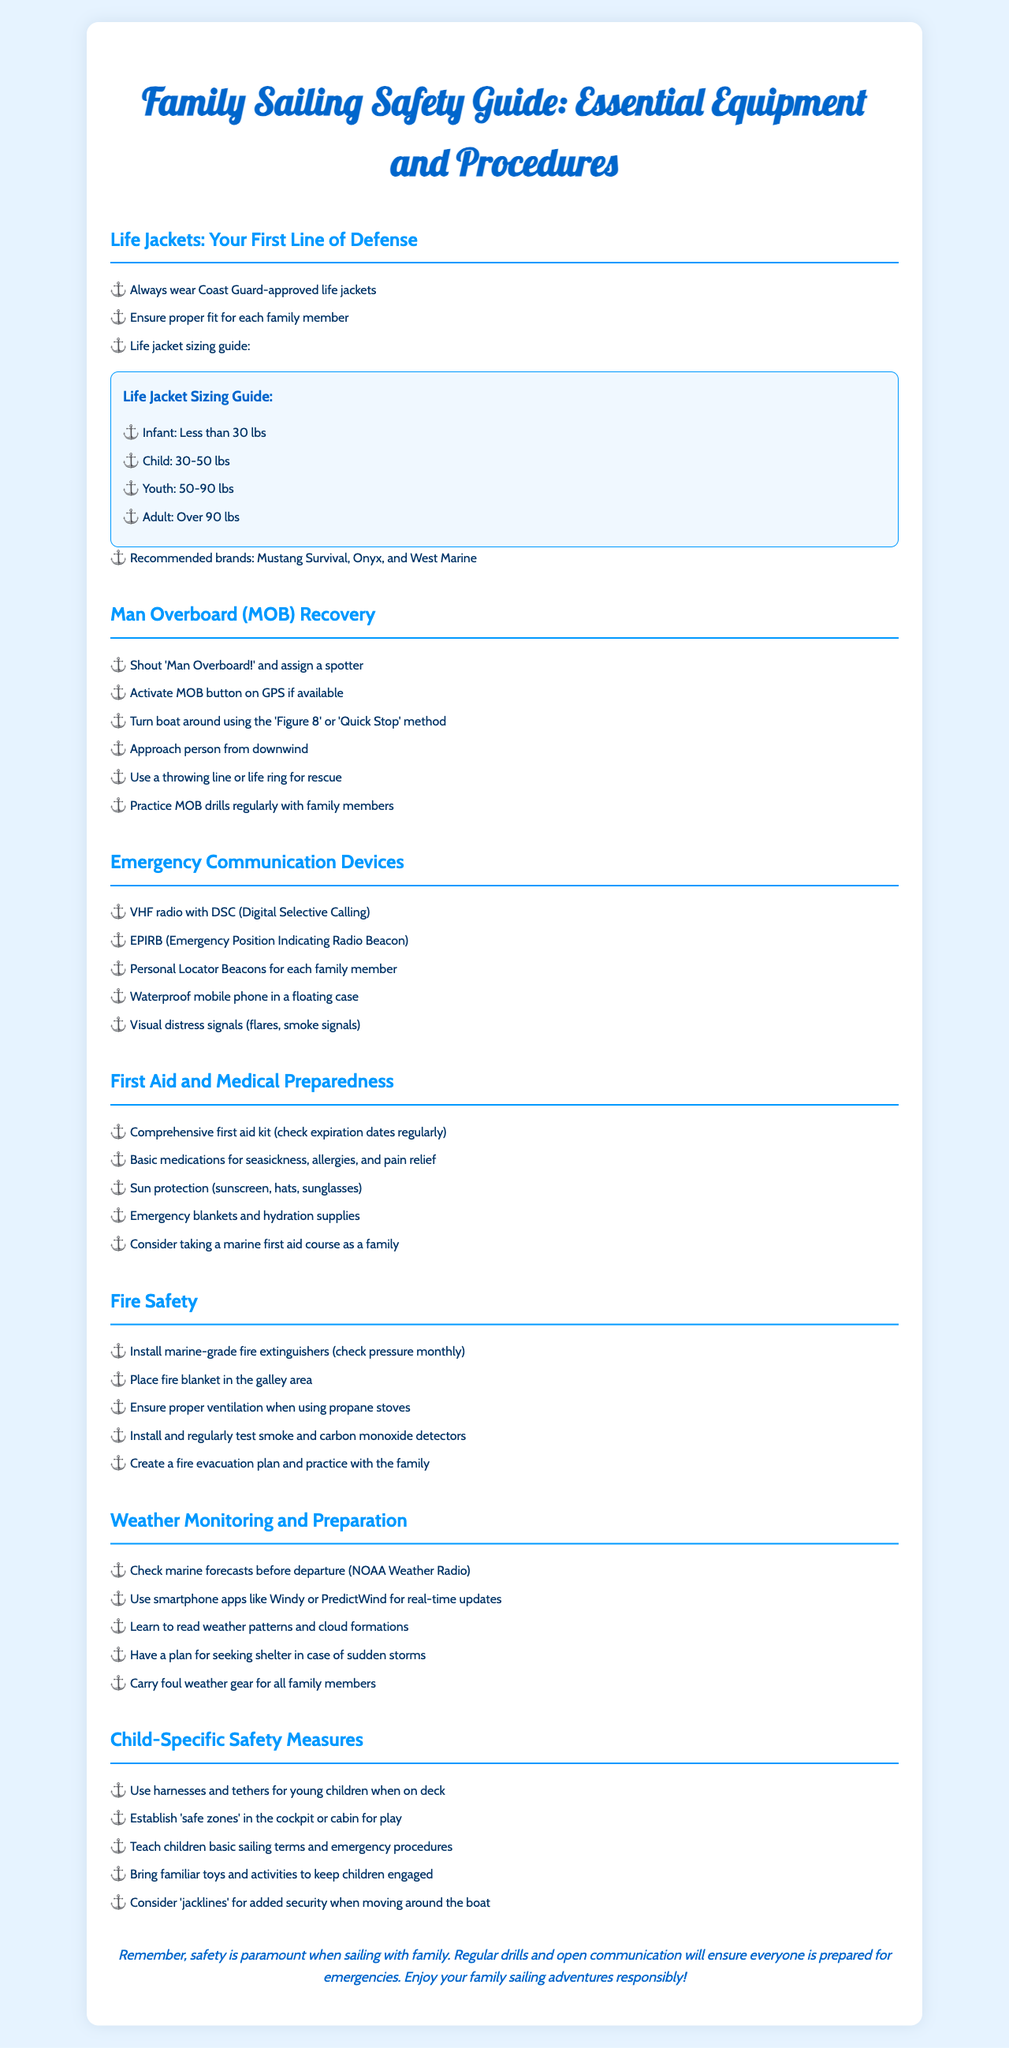what should you always wear when sailing? Always wear Coast Guard-approved life jackets as stated in the document.
Answer: Coast Guard-approved life jackets what is the weight range for an Infant life jacket? The document specifies that an Infant life jacket is for individuals less than 30 lbs.
Answer: Less than 30 lbs what method should you use to turn the boat during a man-overboard situation? The document describes using the 'Figure 8' or 'Quick Stop' method to turn the boat.
Answer: Figure 8 or Quick Stop what type of communication device is recommended for emergency situations? The document lists VHF radio with DSC as one of the recommended communication devices.
Answer: VHF radio with DSC how often should marine-grade fire extinguishers be checked? The document states that marine-grade fire extinguishers should be checked monthly for pressure.
Answer: Monthly what is a critical aspect of child-specific safety measures? The document emphasizes the importance of using harnesses and tethers for young children.
Answer: Harnesses and tethers how can families prepare for unexpected storms? The document suggests carrying foul weather gear for all family members and having a shelter plan.
Answer: Foul weather gear and shelter plan what should be included in a comprehensive first aid kit? The document mentions that a comprehensive first aid kit should have basic medications and supplies.
Answer: Basic medications and supplies what is the main conclusion of the document? The document emphasizes that safety is paramount when sailing with family and suggests regular drills and communication.
Answer: Safety is paramount when sailing with family 